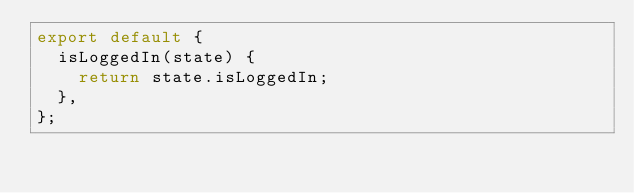Convert code to text. <code><loc_0><loc_0><loc_500><loc_500><_JavaScript_>export default {
  isLoggedIn(state) {
    return state.isLoggedIn;
  },
};
</code> 